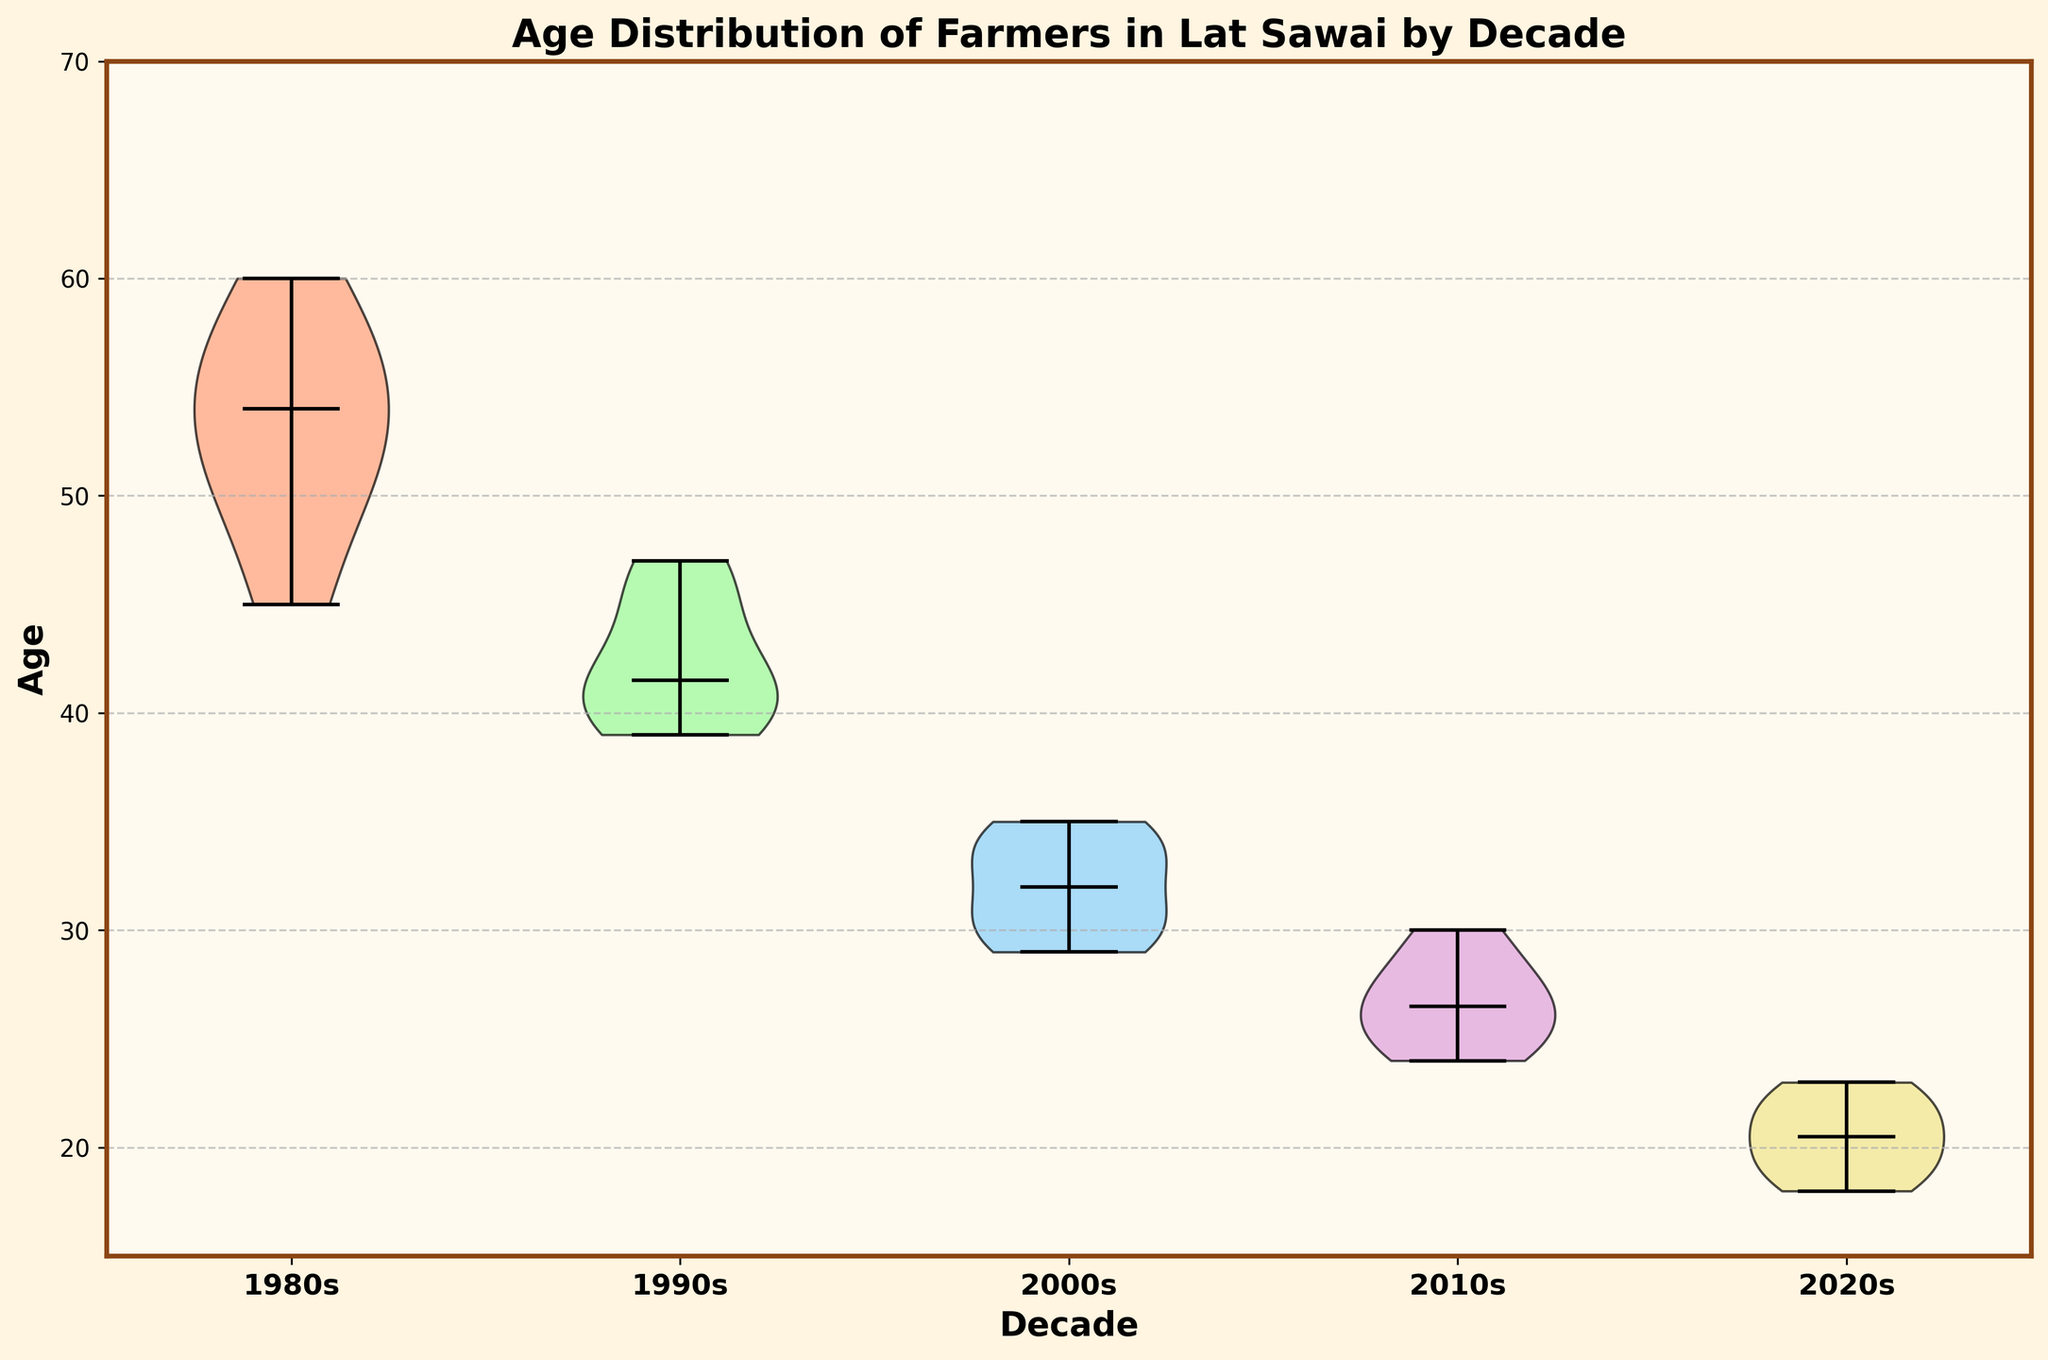What is the title of the figure? The title is usually placed at the top of the figure and describes what the visualization is about.
Answer: Age Distribution of Farmers in Lat Sawai by Decade What are the decades represented on the x-axis? The x-axis labels indicate the decades covered in the dataset. They can be read directly from the bottom of the chart.
Answer: 1980s, 1990s, 2000s, 2010s, 2020s What is the y-axis range of the figure? The range is indicated by the lowest and highest values on the y-axis. By looking at these values on the side of the chart, the range can be determined.
Answer: 15 to 65 Which decade has the youngest group of farmers? By comparing the lowest points of the violin plots, we can see which decade has the youngest age distribution.
Answer: 2020s What is the median age of farmers in the 2000s? The median is shown as a central line within each violin plot. By looking at the 2000s plot, we can find the median age.
Answer: 32 Which decade shows the broadest age distribution? By comparing the width and spread of the violin plots, we can identify the decade with the widest range of ages.
Answer: 1980s How does the median age of farmers change from the 1980s to the 2020s? Look at the median lines for each decade. Subtract the median age in the 2020s from the median age in the 1980s to see the change.
Answer: Decreases by 37 Which decade has the smallest range in ages? By comparing the spread of the violin plots for each decade, we can see which one is the narrowest.
Answer: 2020s What is the average age range for the farmers in the 1990s? Identify the minimum and maximum ages in the 1990s plot and calculate the range: maximum age - minimum age.
Answer: 47 - 39 = 8 How do the shapes of the violin plots reflect the age distributions of each decade? Look at the shape of the plots: wider plots at a certain age indicate more farmers within that age range. Compare these shapes to discuss the distributions.
Answer: The shapes indicate varying numbers of farmers in different age ranges across decades 